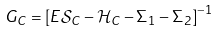Convert formula to latex. <formula><loc_0><loc_0><loc_500><loc_500>G _ { C } = \left [ E { \mathcal { S } } _ { C } - { \mathcal { H } } _ { C } - \Sigma _ { 1 } - \Sigma _ { 2 } \right ] ^ { - 1 }</formula> 